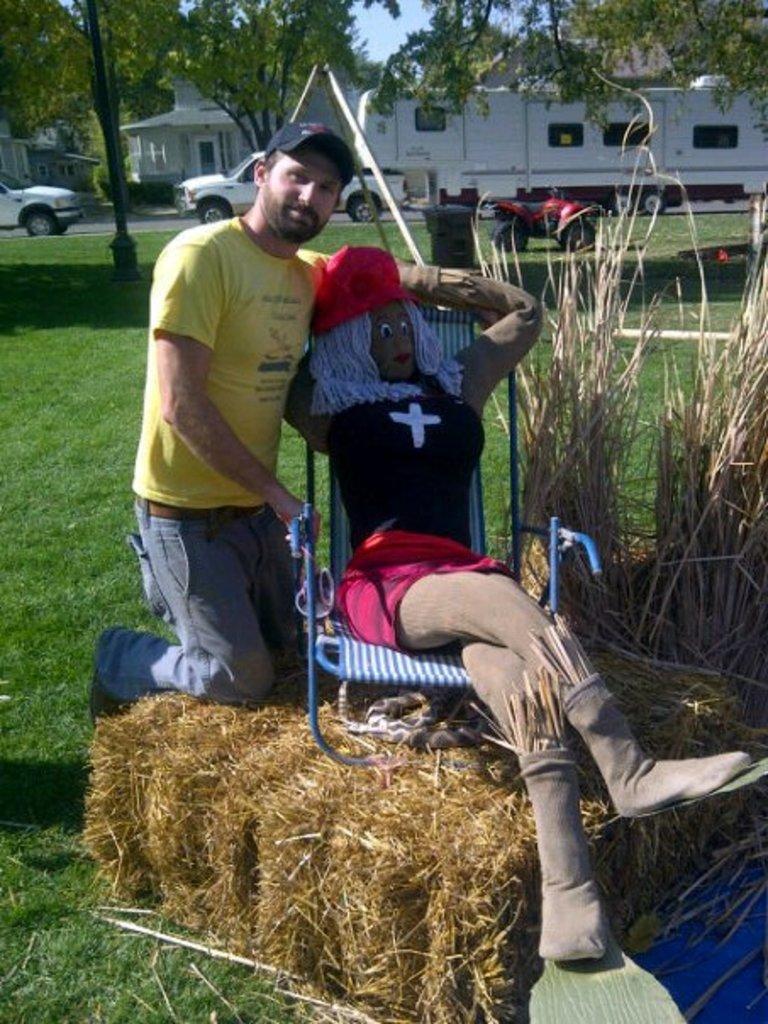How would you summarize this image in a sentence or two? In the picture I can see the hay bale at the bottom of the picture. I can see the statue of a woman sitting on the chair and it is on the hay bale. There is a man on the left side is wearing a yellow color T-shirt and there is a cap on his head. In the background, I can see the vehicles, houses and trees. There is a pole on the top left side. 